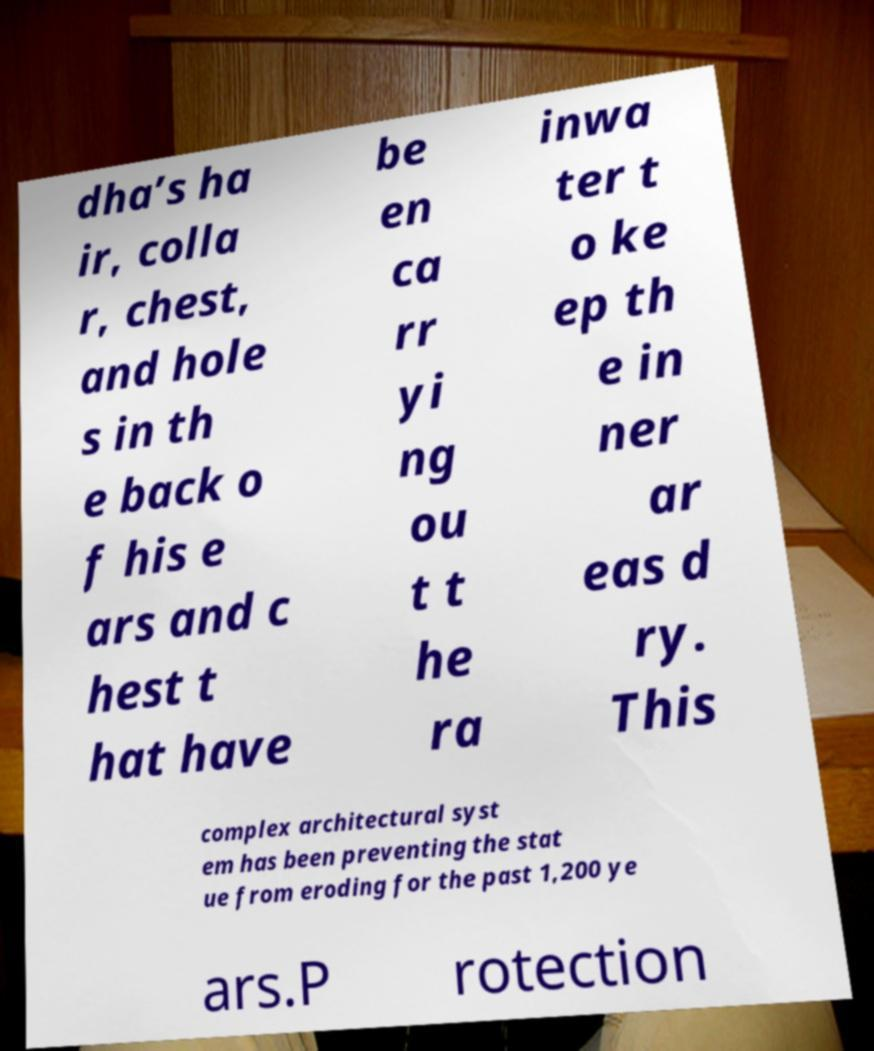What messages or text are displayed in this image? I need them in a readable, typed format. dha’s ha ir, colla r, chest, and hole s in th e back o f his e ars and c hest t hat have be en ca rr yi ng ou t t he ra inwa ter t o ke ep th e in ner ar eas d ry. This complex architectural syst em has been preventing the stat ue from eroding for the past 1,200 ye ars.P rotection 